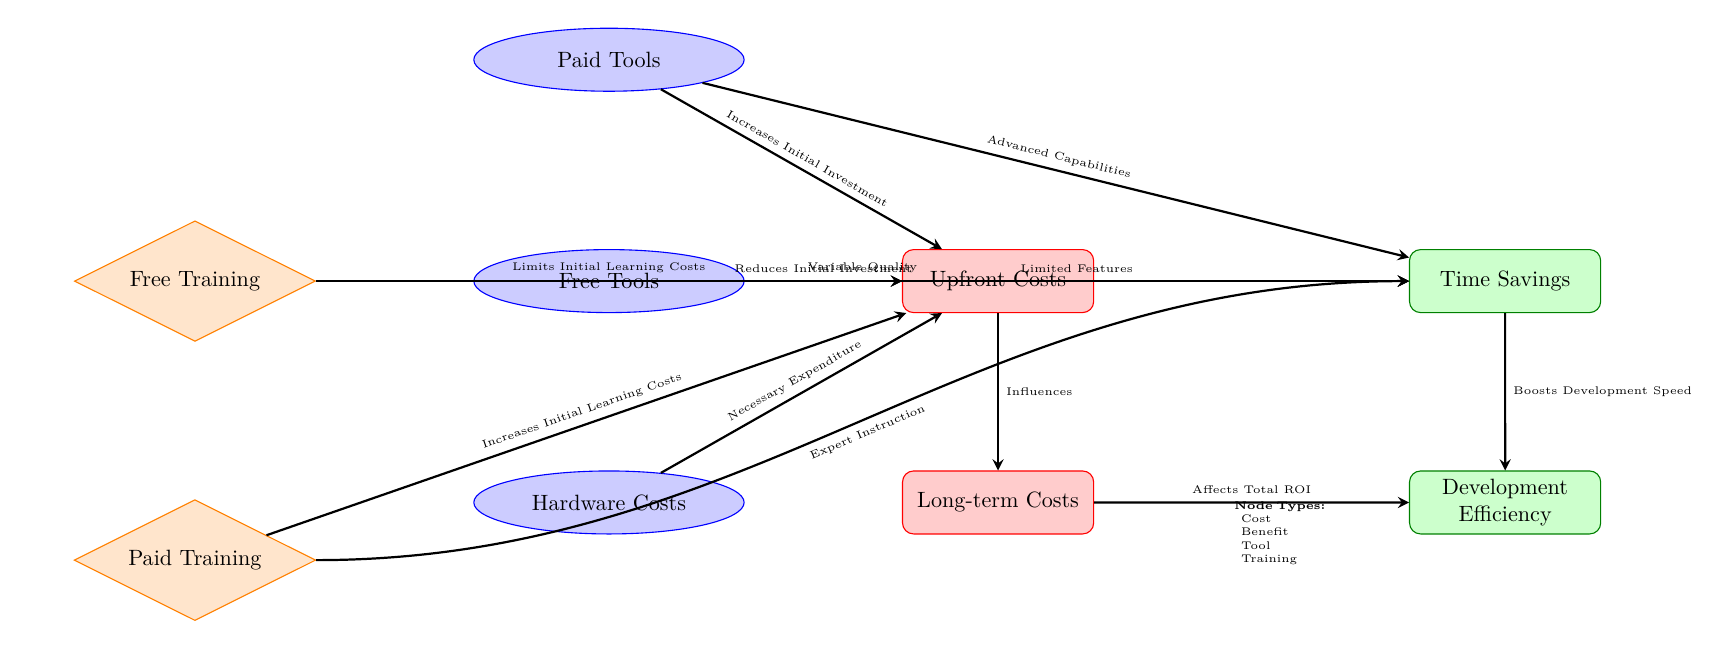What's the type of the node labeled "Free Tools"? In the diagram, "Free Tools" is represented inside an ellipse which follows the style defined for tools. This indicates its type is "Tool."
Answer: Tool What are the two categories of costs depicted in the diagram? The diagram shows two distinct categories of costs: "Upfront Costs" and "Long-term Costs," clearly indicated as red rectangles.
Answer: Upfront Costs, Long-term Costs Which node has a direct relationship indicating it "Increases Initial Investment"? The diagram features an arrow from "Paid Tools" to "Upfront Costs," indicating that paid tools increase initial investment.
Answer: Paid Tools How many benefit nodes are present in the diagram? By counting the rectangles filled with green corresponding to benefits, we identify two nodes: "Time Savings" and "Development Efficiency." Therefore, there are two benefit nodes.
Answer: 2 What effect does "Training Paid" have on "Upfront Costs"? "Training Paid" connects to "Upfront Costs" with an arrow labeled "Increases Initial Learning Costs," indicating that paid training will raise upfront costs.
Answer: Increases Initial Learning Costs What does "Time Savings" influence directly in the diagram? The diagram shows an arrow leading from "Time Savings" to "Development Efficiency," indicating that time savings boosts development efficiency.
Answer: Development Efficiency What might limit the features of the tools in the diagram? The diagram shows an arrow from "Free Tools" to "Time Savings" labeled "Limited Features," indicating that the limitations of free tools may affect time savings.
Answer: Limited Features How does "Long-term Costs" relate to "Development Efficiency"? An arrow connects "Long-term Costs" to "Development Efficiency" labeled "Affects Total ROI," indicating that long-term costs can impact the efficiency of development.
Answer: Affects Total ROI Which training type provides "Expert Instruction"? The node labeled "Training Paid" is connected with an arrow marked "Expert Instruction," indicating it provides expert training.
Answer: Training Paid 